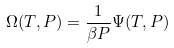Convert formula to latex. <formula><loc_0><loc_0><loc_500><loc_500>\Omega ( T , P ) = \frac { 1 } { \beta P } \Psi ( T , P )</formula> 